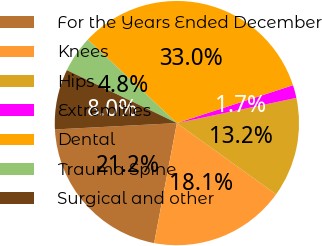Convert chart to OTSL. <chart><loc_0><loc_0><loc_500><loc_500><pie_chart><fcel>For the Years Ended December<fcel>Knees<fcel>Hips<fcel>Extremities<fcel>Dental<fcel>Trauma Spine<fcel>Surgical and other<nl><fcel>21.19%<fcel>18.07%<fcel>13.22%<fcel>1.71%<fcel>33.0%<fcel>4.84%<fcel>7.97%<nl></chart> 